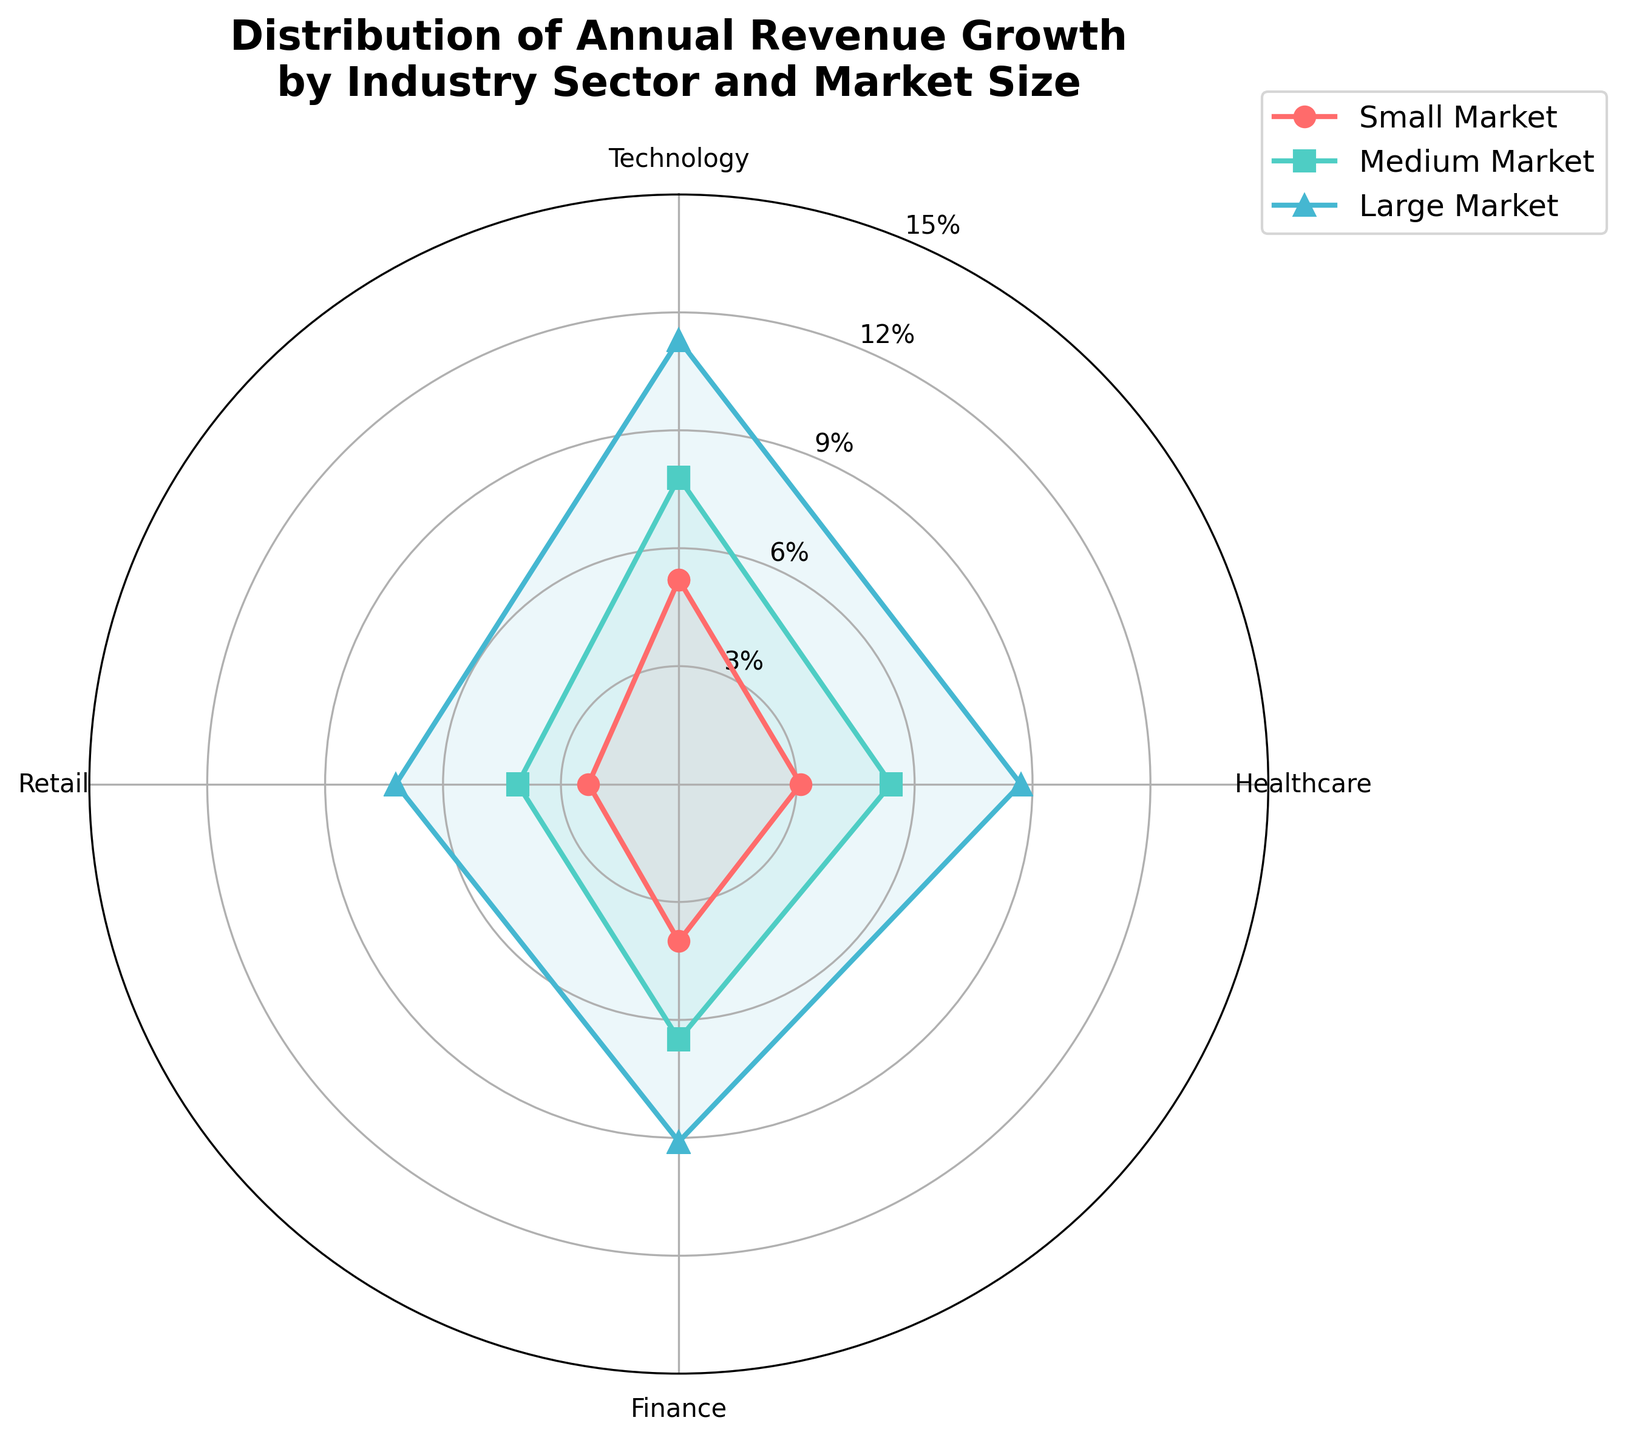What's the title of the figure? The title of the figure is usually found at the top and provides an overview of what the figure represents. In this case, the title is "Distribution of Annual Revenue Growth by Industry Sector and Market Size."
Answer: Distribution of Annual Revenue Growth by Industry Sector and Market Size What are the industry sectors depicted in the radar chart? The industry sectors are listed along the axes of the radar chart. They are "Technology," "Healthcare," "Finance," and "Retail."
Answer: Technology, Healthcare, Finance, Retail Which market size has the highest revenue growth in the Technology sector? Looking at the Technology sector's axis, the values for Small, Medium, and Large Markets are plotted. The Enterprise Market is not plotted. The value for the Medium Market is the highest at 7.8%.
Answer: Medium Market What is the smallest revenue growth percentage shown in the chart? By examining the radial ticks and data points, the smallest value depicted in the chart is for the Retail sector in the Small Market, which is 2.3%.
Answer: 2.3% Compare the revenue growth between the Small Market in the Healthcare sector and the Small Market in the Retail sector. Which is higher? Locate the Small Market section on each sector's axis (Healthcare and Retail). The values are 3.1% for Healthcare and 2.3% for Retail. Comparing these, Healthcare is higher.
Answer: Healthcare What sector has the highest average revenue growth across Small, Medium, and Large Market sizes? To determine the average growth across these three market sizes, sum the values for each sector and divide by three:
- Technology: (5.2 + 7.8 + 11.3) / 3 = 8.1%
- Healthcare: (3.1 + 5.4 + 8.7) / 3 = 5.73%
- Finance: (4.0 + 6.5 + 9.1) / 3 = 6.53%
- Retail: (2.3 + 4.1 + 7.2) / 3 = 4.53%
Technology has the highest average of 8.1%.
Answer: Technology Is the revenue growth for the Medium Market in the Finance sector greater than the Large Market in the Retail sector? Identify the respective values from the chart. The Medium Market for Finance is 6.5% and the Large Market for Retail is 7.2%. Since 6.5% is not greater than 7.2%, the answer is no.
Answer: No Which market size group shows the most consistent revenue growth across all four sectors? Consistency can be inferred from small variations between values across sectors. Small Market: [5.2, 3.1, 4.0, 2.3], Medium Market: [7.8, 5.4, 6.5, 4.1], Large Market: [11.3, 8.7, 9.1, 7.2]. The Small Market shows relatively smaller variations compared to others.
Answer: Small Market Which sector has the largest difference in revenue growth between Small Market and Large Market sizes? Calculating the differences:
- Technology: 11.3 - 5.2 = 6.1
- Healthcare: 8.7 - 3.1 = 5.6
- Finance: 9.1 - 4.0 = 5.1
- Retail: 7.2 - 2.3 = 4.9
Therefore, Technology has the largest difference of 6.1.
Answer: Technology 